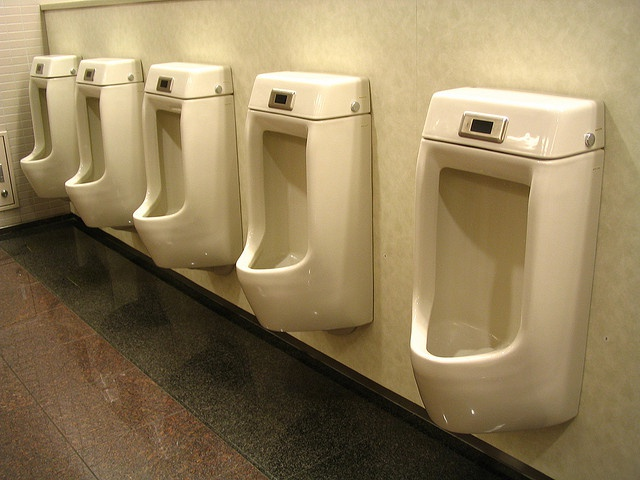Describe the objects in this image and their specific colors. I can see toilet in tan and olive tones, toilet in tan and olive tones, toilet in tan and olive tones, toilet in tan and olive tones, and toilet in tan and olive tones in this image. 